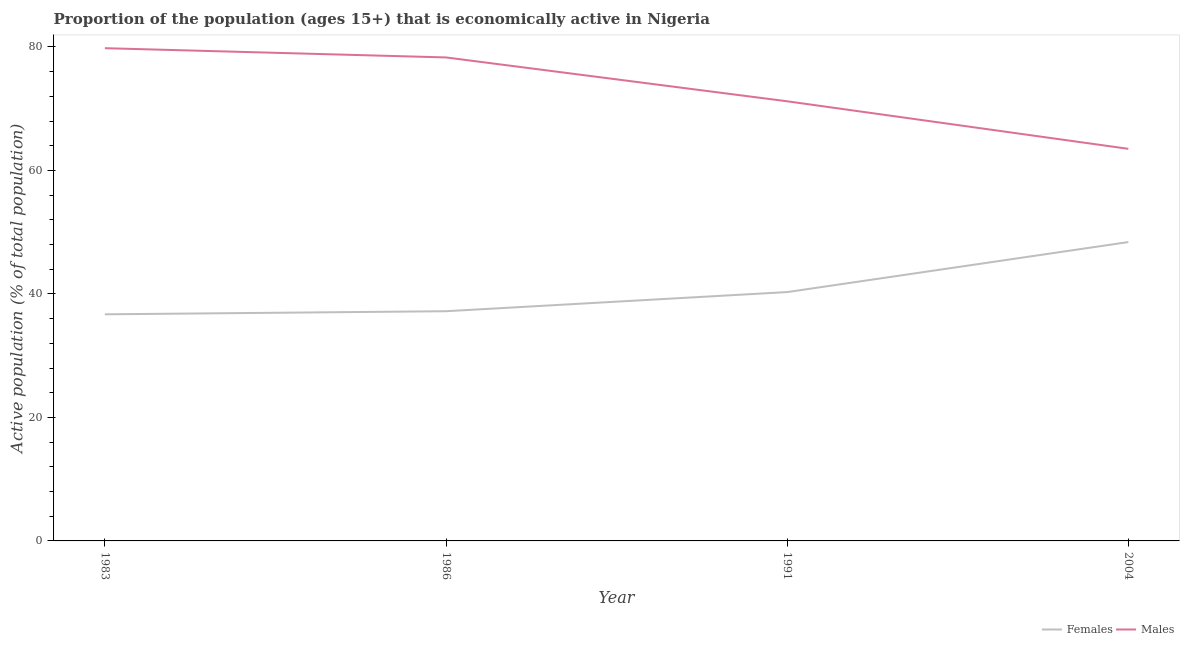Is the number of lines equal to the number of legend labels?
Make the answer very short. Yes. What is the percentage of economically active female population in 1986?
Provide a succinct answer. 37.2. Across all years, what is the maximum percentage of economically active male population?
Ensure brevity in your answer.  79.8. Across all years, what is the minimum percentage of economically active female population?
Offer a very short reply. 36.7. In which year was the percentage of economically active female population maximum?
Offer a very short reply. 2004. In which year was the percentage of economically active male population minimum?
Offer a very short reply. 2004. What is the total percentage of economically active male population in the graph?
Make the answer very short. 292.8. What is the difference between the percentage of economically active female population in 1983 and that in 1991?
Ensure brevity in your answer.  -3.6. What is the difference between the percentage of economically active female population in 1991 and the percentage of economically active male population in 2004?
Keep it short and to the point. -23.2. What is the average percentage of economically active female population per year?
Offer a very short reply. 40.65. In the year 2004, what is the difference between the percentage of economically active female population and percentage of economically active male population?
Offer a terse response. -15.1. In how many years, is the percentage of economically active female population greater than 24 %?
Your answer should be compact. 4. What is the ratio of the percentage of economically active female population in 1986 to that in 1991?
Your response must be concise. 0.92. Is the difference between the percentage of economically active male population in 1986 and 2004 greater than the difference between the percentage of economically active female population in 1986 and 2004?
Offer a very short reply. Yes. What is the difference between the highest and the second highest percentage of economically active female population?
Make the answer very short. 8.1. What is the difference between the highest and the lowest percentage of economically active male population?
Offer a very short reply. 16.3. Is the percentage of economically active male population strictly greater than the percentage of economically active female population over the years?
Your response must be concise. Yes. What is the difference between two consecutive major ticks on the Y-axis?
Provide a succinct answer. 20. Are the values on the major ticks of Y-axis written in scientific E-notation?
Offer a very short reply. No. Where does the legend appear in the graph?
Provide a succinct answer. Bottom right. How many legend labels are there?
Give a very brief answer. 2. How are the legend labels stacked?
Your answer should be very brief. Horizontal. What is the title of the graph?
Your answer should be compact. Proportion of the population (ages 15+) that is economically active in Nigeria. What is the label or title of the Y-axis?
Offer a terse response. Active population (% of total population). What is the Active population (% of total population) in Females in 1983?
Your response must be concise. 36.7. What is the Active population (% of total population) in Males in 1983?
Your answer should be compact. 79.8. What is the Active population (% of total population) of Females in 1986?
Give a very brief answer. 37.2. What is the Active population (% of total population) in Males in 1986?
Give a very brief answer. 78.3. What is the Active population (% of total population) in Females in 1991?
Offer a very short reply. 40.3. What is the Active population (% of total population) in Males in 1991?
Provide a succinct answer. 71.2. What is the Active population (% of total population) of Females in 2004?
Keep it short and to the point. 48.4. What is the Active population (% of total population) of Males in 2004?
Give a very brief answer. 63.5. Across all years, what is the maximum Active population (% of total population) in Females?
Make the answer very short. 48.4. Across all years, what is the maximum Active population (% of total population) in Males?
Ensure brevity in your answer.  79.8. Across all years, what is the minimum Active population (% of total population) of Females?
Provide a short and direct response. 36.7. Across all years, what is the minimum Active population (% of total population) in Males?
Offer a very short reply. 63.5. What is the total Active population (% of total population) of Females in the graph?
Keep it short and to the point. 162.6. What is the total Active population (% of total population) of Males in the graph?
Make the answer very short. 292.8. What is the difference between the Active population (% of total population) of Females in 1983 and that in 1986?
Offer a very short reply. -0.5. What is the difference between the Active population (% of total population) in Males in 1983 and that in 1986?
Offer a terse response. 1.5. What is the difference between the Active population (% of total population) of Females in 1983 and that in 1991?
Provide a succinct answer. -3.6. What is the difference between the Active population (% of total population) in Males in 1983 and that in 1991?
Ensure brevity in your answer.  8.6. What is the difference between the Active population (% of total population) in Females in 1983 and that in 2004?
Your response must be concise. -11.7. What is the difference between the Active population (% of total population) in Females in 1986 and that in 1991?
Keep it short and to the point. -3.1. What is the difference between the Active population (% of total population) in Males in 1986 and that in 1991?
Offer a terse response. 7.1. What is the difference between the Active population (% of total population) of Females in 1986 and that in 2004?
Give a very brief answer. -11.2. What is the difference between the Active population (% of total population) in Females in 1983 and the Active population (% of total population) in Males in 1986?
Provide a succinct answer. -41.6. What is the difference between the Active population (% of total population) of Females in 1983 and the Active population (% of total population) of Males in 1991?
Your answer should be compact. -34.5. What is the difference between the Active population (% of total population) in Females in 1983 and the Active population (% of total population) in Males in 2004?
Provide a succinct answer. -26.8. What is the difference between the Active population (% of total population) of Females in 1986 and the Active population (% of total population) of Males in 1991?
Offer a terse response. -34. What is the difference between the Active population (% of total population) of Females in 1986 and the Active population (% of total population) of Males in 2004?
Offer a very short reply. -26.3. What is the difference between the Active population (% of total population) of Females in 1991 and the Active population (% of total population) of Males in 2004?
Give a very brief answer. -23.2. What is the average Active population (% of total population) of Females per year?
Provide a succinct answer. 40.65. What is the average Active population (% of total population) of Males per year?
Your answer should be compact. 73.2. In the year 1983, what is the difference between the Active population (% of total population) of Females and Active population (% of total population) of Males?
Provide a short and direct response. -43.1. In the year 1986, what is the difference between the Active population (% of total population) in Females and Active population (% of total population) in Males?
Keep it short and to the point. -41.1. In the year 1991, what is the difference between the Active population (% of total population) of Females and Active population (% of total population) of Males?
Provide a short and direct response. -30.9. In the year 2004, what is the difference between the Active population (% of total population) of Females and Active population (% of total population) of Males?
Your answer should be compact. -15.1. What is the ratio of the Active population (% of total population) of Females in 1983 to that in 1986?
Give a very brief answer. 0.99. What is the ratio of the Active population (% of total population) in Males in 1983 to that in 1986?
Keep it short and to the point. 1.02. What is the ratio of the Active population (% of total population) in Females in 1983 to that in 1991?
Give a very brief answer. 0.91. What is the ratio of the Active population (% of total population) in Males in 1983 to that in 1991?
Offer a terse response. 1.12. What is the ratio of the Active population (% of total population) of Females in 1983 to that in 2004?
Your answer should be very brief. 0.76. What is the ratio of the Active population (% of total population) of Males in 1983 to that in 2004?
Your response must be concise. 1.26. What is the ratio of the Active population (% of total population) of Females in 1986 to that in 1991?
Make the answer very short. 0.92. What is the ratio of the Active population (% of total population) in Males in 1986 to that in 1991?
Keep it short and to the point. 1.1. What is the ratio of the Active population (% of total population) of Females in 1986 to that in 2004?
Offer a very short reply. 0.77. What is the ratio of the Active population (% of total population) of Males in 1986 to that in 2004?
Provide a short and direct response. 1.23. What is the ratio of the Active population (% of total population) of Females in 1991 to that in 2004?
Offer a very short reply. 0.83. What is the ratio of the Active population (% of total population) in Males in 1991 to that in 2004?
Provide a short and direct response. 1.12. What is the difference between the highest and the second highest Active population (% of total population) in Females?
Your answer should be very brief. 8.1. What is the difference between the highest and the lowest Active population (% of total population) in Males?
Your answer should be very brief. 16.3. 